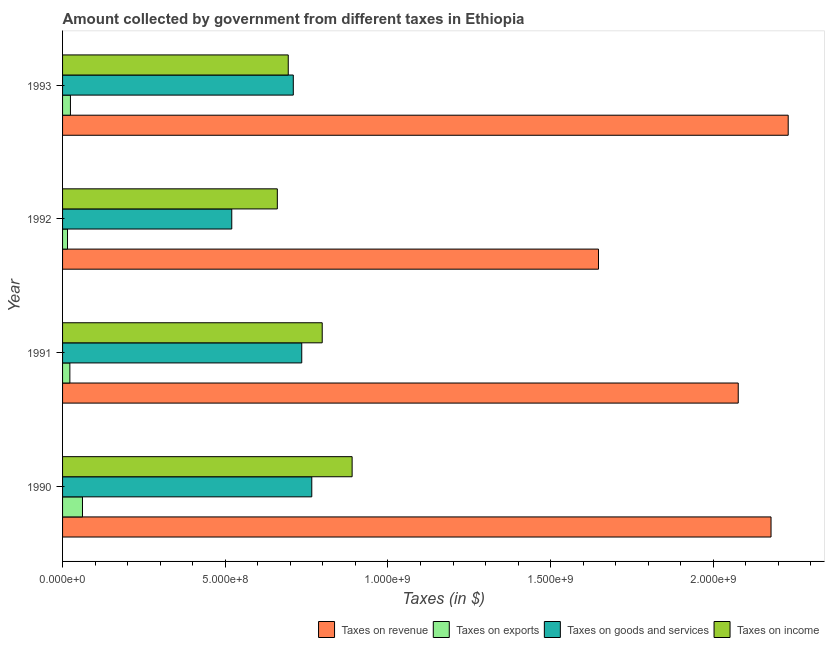How many groups of bars are there?
Keep it short and to the point. 4. Are the number of bars per tick equal to the number of legend labels?
Offer a very short reply. Yes. Are the number of bars on each tick of the Y-axis equal?
Make the answer very short. Yes. How many bars are there on the 3rd tick from the bottom?
Ensure brevity in your answer.  4. What is the amount collected as tax on income in 1991?
Offer a terse response. 7.98e+08. Across all years, what is the maximum amount collected as tax on income?
Make the answer very short. 8.90e+08. Across all years, what is the minimum amount collected as tax on income?
Offer a terse response. 6.60e+08. In which year was the amount collected as tax on income maximum?
Ensure brevity in your answer.  1990. In which year was the amount collected as tax on exports minimum?
Your answer should be very brief. 1992. What is the total amount collected as tax on revenue in the graph?
Offer a terse response. 8.13e+09. What is the difference between the amount collected as tax on income in 1990 and that in 1991?
Ensure brevity in your answer.  9.19e+07. What is the difference between the amount collected as tax on goods in 1991 and the amount collected as tax on income in 1990?
Offer a very short reply. -1.55e+08. What is the average amount collected as tax on goods per year?
Provide a succinct answer. 6.83e+08. In the year 1992, what is the difference between the amount collected as tax on income and amount collected as tax on revenue?
Make the answer very short. -9.87e+08. What is the ratio of the amount collected as tax on exports in 1991 to that in 1992?
Keep it short and to the point. 1.47. Is the amount collected as tax on revenue in 1990 less than that in 1991?
Your answer should be very brief. No. What is the difference between the highest and the second highest amount collected as tax on exports?
Your answer should be compact. 3.70e+07. What is the difference between the highest and the lowest amount collected as tax on exports?
Make the answer very short. 4.60e+07. What does the 1st bar from the top in 1991 represents?
Provide a short and direct response. Taxes on income. What does the 1st bar from the bottom in 1993 represents?
Your response must be concise. Taxes on revenue. Is it the case that in every year, the sum of the amount collected as tax on revenue and amount collected as tax on exports is greater than the amount collected as tax on goods?
Offer a very short reply. Yes. How many bars are there?
Keep it short and to the point. 16. Are all the bars in the graph horizontal?
Offer a terse response. Yes. How many years are there in the graph?
Provide a succinct answer. 4. What is the difference between two consecutive major ticks on the X-axis?
Provide a succinct answer. 5.00e+08. Are the values on the major ticks of X-axis written in scientific E-notation?
Offer a terse response. Yes. Does the graph contain any zero values?
Make the answer very short. No. Does the graph contain grids?
Your answer should be compact. No. Where does the legend appear in the graph?
Make the answer very short. Bottom right. How many legend labels are there?
Offer a very short reply. 4. What is the title of the graph?
Ensure brevity in your answer.  Amount collected by government from different taxes in Ethiopia. What is the label or title of the X-axis?
Keep it short and to the point. Taxes (in $). What is the label or title of the Y-axis?
Keep it short and to the point. Year. What is the Taxes (in $) of Taxes on revenue in 1990?
Ensure brevity in your answer.  2.18e+09. What is the Taxes (in $) in Taxes on exports in 1990?
Your response must be concise. 6.12e+07. What is the Taxes (in $) of Taxes on goods and services in 1990?
Your answer should be very brief. 7.66e+08. What is the Taxes (in $) of Taxes on income in 1990?
Make the answer very short. 8.90e+08. What is the Taxes (in $) of Taxes on revenue in 1991?
Ensure brevity in your answer.  2.08e+09. What is the Taxes (in $) of Taxes on exports in 1991?
Offer a very short reply. 2.24e+07. What is the Taxes (in $) in Taxes on goods and services in 1991?
Your answer should be compact. 7.35e+08. What is the Taxes (in $) in Taxes on income in 1991?
Provide a succinct answer. 7.98e+08. What is the Taxes (in $) of Taxes on revenue in 1992?
Your response must be concise. 1.65e+09. What is the Taxes (in $) of Taxes on exports in 1992?
Give a very brief answer. 1.52e+07. What is the Taxes (in $) of Taxes on goods and services in 1992?
Keep it short and to the point. 5.20e+08. What is the Taxes (in $) in Taxes on income in 1992?
Provide a succinct answer. 6.60e+08. What is the Taxes (in $) of Taxes on revenue in 1993?
Offer a very short reply. 2.23e+09. What is the Taxes (in $) of Taxes on exports in 1993?
Ensure brevity in your answer.  2.42e+07. What is the Taxes (in $) of Taxes on goods and services in 1993?
Give a very brief answer. 7.09e+08. What is the Taxes (in $) of Taxes on income in 1993?
Keep it short and to the point. 6.94e+08. Across all years, what is the maximum Taxes (in $) of Taxes on revenue?
Make the answer very short. 2.23e+09. Across all years, what is the maximum Taxes (in $) of Taxes on exports?
Your response must be concise. 6.12e+07. Across all years, what is the maximum Taxes (in $) in Taxes on goods and services?
Your answer should be very brief. 7.66e+08. Across all years, what is the maximum Taxes (in $) in Taxes on income?
Your response must be concise. 8.90e+08. Across all years, what is the minimum Taxes (in $) of Taxes on revenue?
Give a very brief answer. 1.65e+09. Across all years, what is the minimum Taxes (in $) of Taxes on exports?
Provide a succinct answer. 1.52e+07. Across all years, what is the minimum Taxes (in $) in Taxes on goods and services?
Provide a short and direct response. 5.20e+08. Across all years, what is the minimum Taxes (in $) of Taxes on income?
Offer a terse response. 6.60e+08. What is the total Taxes (in $) of Taxes on revenue in the graph?
Offer a terse response. 8.13e+09. What is the total Taxes (in $) of Taxes on exports in the graph?
Offer a terse response. 1.23e+08. What is the total Taxes (in $) in Taxes on goods and services in the graph?
Ensure brevity in your answer.  2.73e+09. What is the total Taxes (in $) of Taxes on income in the graph?
Make the answer very short. 3.04e+09. What is the difference between the Taxes (in $) in Taxes on revenue in 1990 and that in 1991?
Make the answer very short. 1.01e+08. What is the difference between the Taxes (in $) of Taxes on exports in 1990 and that in 1991?
Offer a terse response. 3.88e+07. What is the difference between the Taxes (in $) in Taxes on goods and services in 1990 and that in 1991?
Give a very brief answer. 3.08e+07. What is the difference between the Taxes (in $) of Taxes on income in 1990 and that in 1991?
Ensure brevity in your answer.  9.19e+07. What is the difference between the Taxes (in $) of Taxes on revenue in 1990 and that in 1992?
Offer a terse response. 5.30e+08. What is the difference between the Taxes (in $) in Taxes on exports in 1990 and that in 1992?
Your answer should be very brief. 4.60e+07. What is the difference between the Taxes (in $) in Taxes on goods and services in 1990 and that in 1992?
Offer a very short reply. 2.46e+08. What is the difference between the Taxes (in $) in Taxes on income in 1990 and that in 1992?
Keep it short and to the point. 2.30e+08. What is the difference between the Taxes (in $) in Taxes on revenue in 1990 and that in 1993?
Make the answer very short. -5.28e+07. What is the difference between the Taxes (in $) of Taxes on exports in 1990 and that in 1993?
Make the answer very short. 3.70e+07. What is the difference between the Taxes (in $) of Taxes on goods and services in 1990 and that in 1993?
Offer a very short reply. 5.68e+07. What is the difference between the Taxes (in $) of Taxes on income in 1990 and that in 1993?
Provide a short and direct response. 1.96e+08. What is the difference between the Taxes (in $) in Taxes on revenue in 1991 and that in 1992?
Provide a succinct answer. 4.30e+08. What is the difference between the Taxes (in $) in Taxes on exports in 1991 and that in 1992?
Make the answer very short. 7.20e+06. What is the difference between the Taxes (in $) of Taxes on goods and services in 1991 and that in 1992?
Offer a terse response. 2.15e+08. What is the difference between the Taxes (in $) in Taxes on income in 1991 and that in 1992?
Your response must be concise. 1.38e+08. What is the difference between the Taxes (in $) in Taxes on revenue in 1991 and that in 1993?
Your response must be concise. -1.54e+08. What is the difference between the Taxes (in $) in Taxes on exports in 1991 and that in 1993?
Provide a succinct answer. -1.80e+06. What is the difference between the Taxes (in $) of Taxes on goods and services in 1991 and that in 1993?
Provide a succinct answer. 2.60e+07. What is the difference between the Taxes (in $) in Taxes on income in 1991 and that in 1993?
Your answer should be very brief. 1.04e+08. What is the difference between the Taxes (in $) in Taxes on revenue in 1992 and that in 1993?
Give a very brief answer. -5.83e+08. What is the difference between the Taxes (in $) in Taxes on exports in 1992 and that in 1993?
Offer a terse response. -9.00e+06. What is the difference between the Taxes (in $) of Taxes on goods and services in 1992 and that in 1993?
Ensure brevity in your answer.  -1.89e+08. What is the difference between the Taxes (in $) of Taxes on income in 1992 and that in 1993?
Your response must be concise. -3.36e+07. What is the difference between the Taxes (in $) of Taxes on revenue in 1990 and the Taxes (in $) of Taxes on exports in 1991?
Your answer should be very brief. 2.15e+09. What is the difference between the Taxes (in $) of Taxes on revenue in 1990 and the Taxes (in $) of Taxes on goods and services in 1991?
Provide a short and direct response. 1.44e+09. What is the difference between the Taxes (in $) in Taxes on revenue in 1990 and the Taxes (in $) in Taxes on income in 1991?
Give a very brief answer. 1.38e+09. What is the difference between the Taxes (in $) of Taxes on exports in 1990 and the Taxes (in $) of Taxes on goods and services in 1991?
Provide a short and direct response. -6.74e+08. What is the difference between the Taxes (in $) of Taxes on exports in 1990 and the Taxes (in $) of Taxes on income in 1991?
Give a very brief answer. -7.37e+08. What is the difference between the Taxes (in $) in Taxes on goods and services in 1990 and the Taxes (in $) in Taxes on income in 1991?
Your response must be concise. -3.21e+07. What is the difference between the Taxes (in $) in Taxes on revenue in 1990 and the Taxes (in $) in Taxes on exports in 1992?
Keep it short and to the point. 2.16e+09. What is the difference between the Taxes (in $) of Taxes on revenue in 1990 and the Taxes (in $) of Taxes on goods and services in 1992?
Keep it short and to the point. 1.66e+09. What is the difference between the Taxes (in $) in Taxes on revenue in 1990 and the Taxes (in $) in Taxes on income in 1992?
Offer a very short reply. 1.52e+09. What is the difference between the Taxes (in $) in Taxes on exports in 1990 and the Taxes (in $) in Taxes on goods and services in 1992?
Offer a terse response. -4.59e+08. What is the difference between the Taxes (in $) of Taxes on exports in 1990 and the Taxes (in $) of Taxes on income in 1992?
Your answer should be very brief. -5.99e+08. What is the difference between the Taxes (in $) of Taxes on goods and services in 1990 and the Taxes (in $) of Taxes on income in 1992?
Your answer should be compact. 1.06e+08. What is the difference between the Taxes (in $) in Taxes on revenue in 1990 and the Taxes (in $) in Taxes on exports in 1993?
Your answer should be compact. 2.15e+09. What is the difference between the Taxes (in $) of Taxes on revenue in 1990 and the Taxes (in $) of Taxes on goods and services in 1993?
Make the answer very short. 1.47e+09. What is the difference between the Taxes (in $) of Taxes on revenue in 1990 and the Taxes (in $) of Taxes on income in 1993?
Your answer should be very brief. 1.48e+09. What is the difference between the Taxes (in $) in Taxes on exports in 1990 and the Taxes (in $) in Taxes on goods and services in 1993?
Offer a very short reply. -6.48e+08. What is the difference between the Taxes (in $) in Taxes on exports in 1990 and the Taxes (in $) in Taxes on income in 1993?
Ensure brevity in your answer.  -6.32e+08. What is the difference between the Taxes (in $) of Taxes on goods and services in 1990 and the Taxes (in $) of Taxes on income in 1993?
Provide a succinct answer. 7.23e+07. What is the difference between the Taxes (in $) of Taxes on revenue in 1991 and the Taxes (in $) of Taxes on exports in 1992?
Ensure brevity in your answer.  2.06e+09. What is the difference between the Taxes (in $) in Taxes on revenue in 1991 and the Taxes (in $) in Taxes on goods and services in 1992?
Make the answer very short. 1.56e+09. What is the difference between the Taxes (in $) in Taxes on revenue in 1991 and the Taxes (in $) in Taxes on income in 1992?
Keep it short and to the point. 1.42e+09. What is the difference between the Taxes (in $) of Taxes on exports in 1991 and the Taxes (in $) of Taxes on goods and services in 1992?
Offer a very short reply. -4.98e+08. What is the difference between the Taxes (in $) in Taxes on exports in 1991 and the Taxes (in $) in Taxes on income in 1992?
Give a very brief answer. -6.38e+08. What is the difference between the Taxes (in $) of Taxes on goods and services in 1991 and the Taxes (in $) of Taxes on income in 1992?
Offer a very short reply. 7.51e+07. What is the difference between the Taxes (in $) of Taxes on revenue in 1991 and the Taxes (in $) of Taxes on exports in 1993?
Make the answer very short. 2.05e+09. What is the difference between the Taxes (in $) in Taxes on revenue in 1991 and the Taxes (in $) in Taxes on goods and services in 1993?
Provide a short and direct response. 1.37e+09. What is the difference between the Taxes (in $) of Taxes on revenue in 1991 and the Taxes (in $) of Taxes on income in 1993?
Provide a succinct answer. 1.38e+09. What is the difference between the Taxes (in $) of Taxes on exports in 1991 and the Taxes (in $) of Taxes on goods and services in 1993?
Offer a terse response. -6.87e+08. What is the difference between the Taxes (in $) in Taxes on exports in 1991 and the Taxes (in $) in Taxes on income in 1993?
Your answer should be very brief. -6.71e+08. What is the difference between the Taxes (in $) in Taxes on goods and services in 1991 and the Taxes (in $) in Taxes on income in 1993?
Keep it short and to the point. 4.15e+07. What is the difference between the Taxes (in $) of Taxes on revenue in 1992 and the Taxes (in $) of Taxes on exports in 1993?
Ensure brevity in your answer.  1.62e+09. What is the difference between the Taxes (in $) in Taxes on revenue in 1992 and the Taxes (in $) in Taxes on goods and services in 1993?
Provide a succinct answer. 9.38e+08. What is the difference between the Taxes (in $) of Taxes on revenue in 1992 and the Taxes (in $) of Taxes on income in 1993?
Give a very brief answer. 9.53e+08. What is the difference between the Taxes (in $) in Taxes on exports in 1992 and the Taxes (in $) in Taxes on goods and services in 1993?
Your response must be concise. -6.94e+08. What is the difference between the Taxes (in $) in Taxes on exports in 1992 and the Taxes (in $) in Taxes on income in 1993?
Provide a short and direct response. -6.78e+08. What is the difference between the Taxes (in $) in Taxes on goods and services in 1992 and the Taxes (in $) in Taxes on income in 1993?
Keep it short and to the point. -1.74e+08. What is the average Taxes (in $) of Taxes on revenue per year?
Make the answer very short. 2.03e+09. What is the average Taxes (in $) in Taxes on exports per year?
Your answer should be very brief. 3.08e+07. What is the average Taxes (in $) in Taxes on goods and services per year?
Offer a terse response. 6.83e+08. What is the average Taxes (in $) in Taxes on income per year?
Your answer should be compact. 7.60e+08. In the year 1990, what is the difference between the Taxes (in $) of Taxes on revenue and Taxes (in $) of Taxes on exports?
Provide a short and direct response. 2.12e+09. In the year 1990, what is the difference between the Taxes (in $) of Taxes on revenue and Taxes (in $) of Taxes on goods and services?
Provide a succinct answer. 1.41e+09. In the year 1990, what is the difference between the Taxes (in $) of Taxes on revenue and Taxes (in $) of Taxes on income?
Offer a terse response. 1.29e+09. In the year 1990, what is the difference between the Taxes (in $) of Taxes on exports and Taxes (in $) of Taxes on goods and services?
Your answer should be very brief. -7.05e+08. In the year 1990, what is the difference between the Taxes (in $) in Taxes on exports and Taxes (in $) in Taxes on income?
Offer a very short reply. -8.29e+08. In the year 1990, what is the difference between the Taxes (in $) of Taxes on goods and services and Taxes (in $) of Taxes on income?
Keep it short and to the point. -1.24e+08. In the year 1991, what is the difference between the Taxes (in $) of Taxes on revenue and Taxes (in $) of Taxes on exports?
Provide a succinct answer. 2.05e+09. In the year 1991, what is the difference between the Taxes (in $) in Taxes on revenue and Taxes (in $) in Taxes on goods and services?
Provide a succinct answer. 1.34e+09. In the year 1991, what is the difference between the Taxes (in $) of Taxes on revenue and Taxes (in $) of Taxes on income?
Your answer should be very brief. 1.28e+09. In the year 1991, what is the difference between the Taxes (in $) of Taxes on exports and Taxes (in $) of Taxes on goods and services?
Ensure brevity in your answer.  -7.13e+08. In the year 1991, what is the difference between the Taxes (in $) in Taxes on exports and Taxes (in $) in Taxes on income?
Give a very brief answer. -7.76e+08. In the year 1991, what is the difference between the Taxes (in $) in Taxes on goods and services and Taxes (in $) in Taxes on income?
Your answer should be compact. -6.29e+07. In the year 1992, what is the difference between the Taxes (in $) in Taxes on revenue and Taxes (in $) in Taxes on exports?
Ensure brevity in your answer.  1.63e+09. In the year 1992, what is the difference between the Taxes (in $) in Taxes on revenue and Taxes (in $) in Taxes on goods and services?
Make the answer very short. 1.13e+09. In the year 1992, what is the difference between the Taxes (in $) in Taxes on revenue and Taxes (in $) in Taxes on income?
Your answer should be very brief. 9.87e+08. In the year 1992, what is the difference between the Taxes (in $) of Taxes on exports and Taxes (in $) of Taxes on goods and services?
Give a very brief answer. -5.05e+08. In the year 1992, what is the difference between the Taxes (in $) of Taxes on exports and Taxes (in $) of Taxes on income?
Your answer should be very brief. -6.45e+08. In the year 1992, what is the difference between the Taxes (in $) of Taxes on goods and services and Taxes (in $) of Taxes on income?
Offer a very short reply. -1.40e+08. In the year 1993, what is the difference between the Taxes (in $) in Taxes on revenue and Taxes (in $) in Taxes on exports?
Ensure brevity in your answer.  2.21e+09. In the year 1993, what is the difference between the Taxes (in $) in Taxes on revenue and Taxes (in $) in Taxes on goods and services?
Offer a terse response. 1.52e+09. In the year 1993, what is the difference between the Taxes (in $) of Taxes on revenue and Taxes (in $) of Taxes on income?
Offer a very short reply. 1.54e+09. In the year 1993, what is the difference between the Taxes (in $) of Taxes on exports and Taxes (in $) of Taxes on goods and services?
Make the answer very short. -6.85e+08. In the year 1993, what is the difference between the Taxes (in $) in Taxes on exports and Taxes (in $) in Taxes on income?
Your answer should be compact. -6.69e+08. In the year 1993, what is the difference between the Taxes (in $) of Taxes on goods and services and Taxes (in $) of Taxes on income?
Give a very brief answer. 1.55e+07. What is the ratio of the Taxes (in $) of Taxes on revenue in 1990 to that in 1991?
Your answer should be compact. 1.05. What is the ratio of the Taxes (in $) of Taxes on exports in 1990 to that in 1991?
Make the answer very short. 2.73. What is the ratio of the Taxes (in $) of Taxes on goods and services in 1990 to that in 1991?
Your answer should be compact. 1.04. What is the ratio of the Taxes (in $) of Taxes on income in 1990 to that in 1991?
Ensure brevity in your answer.  1.12. What is the ratio of the Taxes (in $) of Taxes on revenue in 1990 to that in 1992?
Make the answer very short. 1.32. What is the ratio of the Taxes (in $) of Taxes on exports in 1990 to that in 1992?
Keep it short and to the point. 4.03. What is the ratio of the Taxes (in $) in Taxes on goods and services in 1990 to that in 1992?
Give a very brief answer. 1.47. What is the ratio of the Taxes (in $) in Taxes on income in 1990 to that in 1992?
Offer a very short reply. 1.35. What is the ratio of the Taxes (in $) in Taxes on revenue in 1990 to that in 1993?
Give a very brief answer. 0.98. What is the ratio of the Taxes (in $) in Taxes on exports in 1990 to that in 1993?
Make the answer very short. 2.53. What is the ratio of the Taxes (in $) of Taxes on goods and services in 1990 to that in 1993?
Provide a short and direct response. 1.08. What is the ratio of the Taxes (in $) of Taxes on income in 1990 to that in 1993?
Your response must be concise. 1.28. What is the ratio of the Taxes (in $) in Taxes on revenue in 1991 to that in 1992?
Make the answer very short. 1.26. What is the ratio of the Taxes (in $) in Taxes on exports in 1991 to that in 1992?
Provide a short and direct response. 1.47. What is the ratio of the Taxes (in $) of Taxes on goods and services in 1991 to that in 1992?
Provide a short and direct response. 1.41. What is the ratio of the Taxes (in $) in Taxes on income in 1991 to that in 1992?
Your answer should be very brief. 1.21. What is the ratio of the Taxes (in $) in Taxes on revenue in 1991 to that in 1993?
Your answer should be very brief. 0.93. What is the ratio of the Taxes (in $) of Taxes on exports in 1991 to that in 1993?
Provide a short and direct response. 0.93. What is the ratio of the Taxes (in $) in Taxes on goods and services in 1991 to that in 1993?
Provide a succinct answer. 1.04. What is the ratio of the Taxes (in $) of Taxes on income in 1991 to that in 1993?
Provide a succinct answer. 1.15. What is the ratio of the Taxes (in $) in Taxes on revenue in 1992 to that in 1993?
Provide a succinct answer. 0.74. What is the ratio of the Taxes (in $) of Taxes on exports in 1992 to that in 1993?
Your answer should be very brief. 0.63. What is the ratio of the Taxes (in $) of Taxes on goods and services in 1992 to that in 1993?
Your response must be concise. 0.73. What is the ratio of the Taxes (in $) in Taxes on income in 1992 to that in 1993?
Ensure brevity in your answer.  0.95. What is the difference between the highest and the second highest Taxes (in $) in Taxes on revenue?
Offer a terse response. 5.28e+07. What is the difference between the highest and the second highest Taxes (in $) in Taxes on exports?
Make the answer very short. 3.70e+07. What is the difference between the highest and the second highest Taxes (in $) of Taxes on goods and services?
Make the answer very short. 3.08e+07. What is the difference between the highest and the second highest Taxes (in $) in Taxes on income?
Give a very brief answer. 9.19e+07. What is the difference between the highest and the lowest Taxes (in $) of Taxes on revenue?
Provide a short and direct response. 5.83e+08. What is the difference between the highest and the lowest Taxes (in $) of Taxes on exports?
Provide a succinct answer. 4.60e+07. What is the difference between the highest and the lowest Taxes (in $) in Taxes on goods and services?
Offer a very short reply. 2.46e+08. What is the difference between the highest and the lowest Taxes (in $) of Taxes on income?
Offer a very short reply. 2.30e+08. 